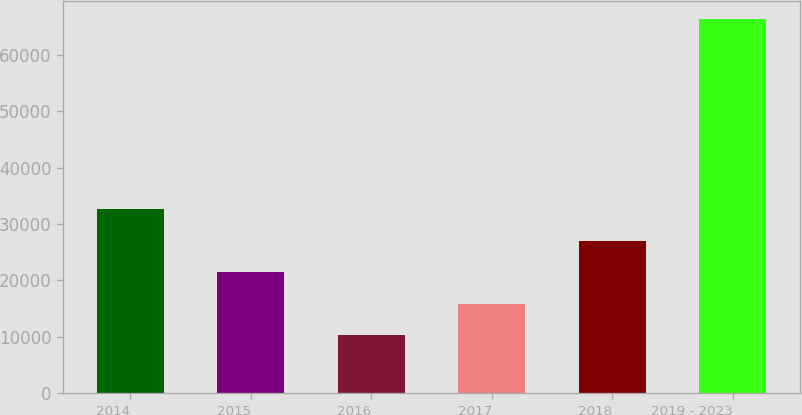Convert chart. <chart><loc_0><loc_0><loc_500><loc_500><bar_chart><fcel>2014<fcel>2015<fcel>2016<fcel>2017<fcel>2018<fcel>2019 - 2023<nl><fcel>32672<fcel>21457<fcel>10242<fcel>15849.5<fcel>27064.5<fcel>66317<nl></chart> 